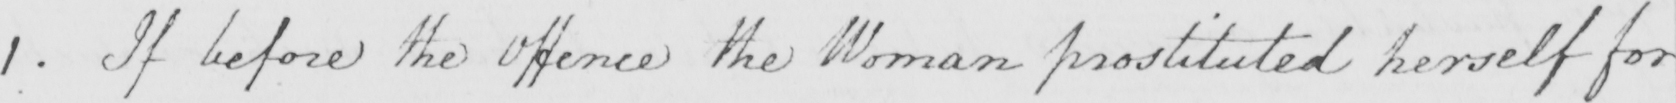Can you tell me what this handwritten text says? 1 . If before the Offence the Woman prostituted herself for 